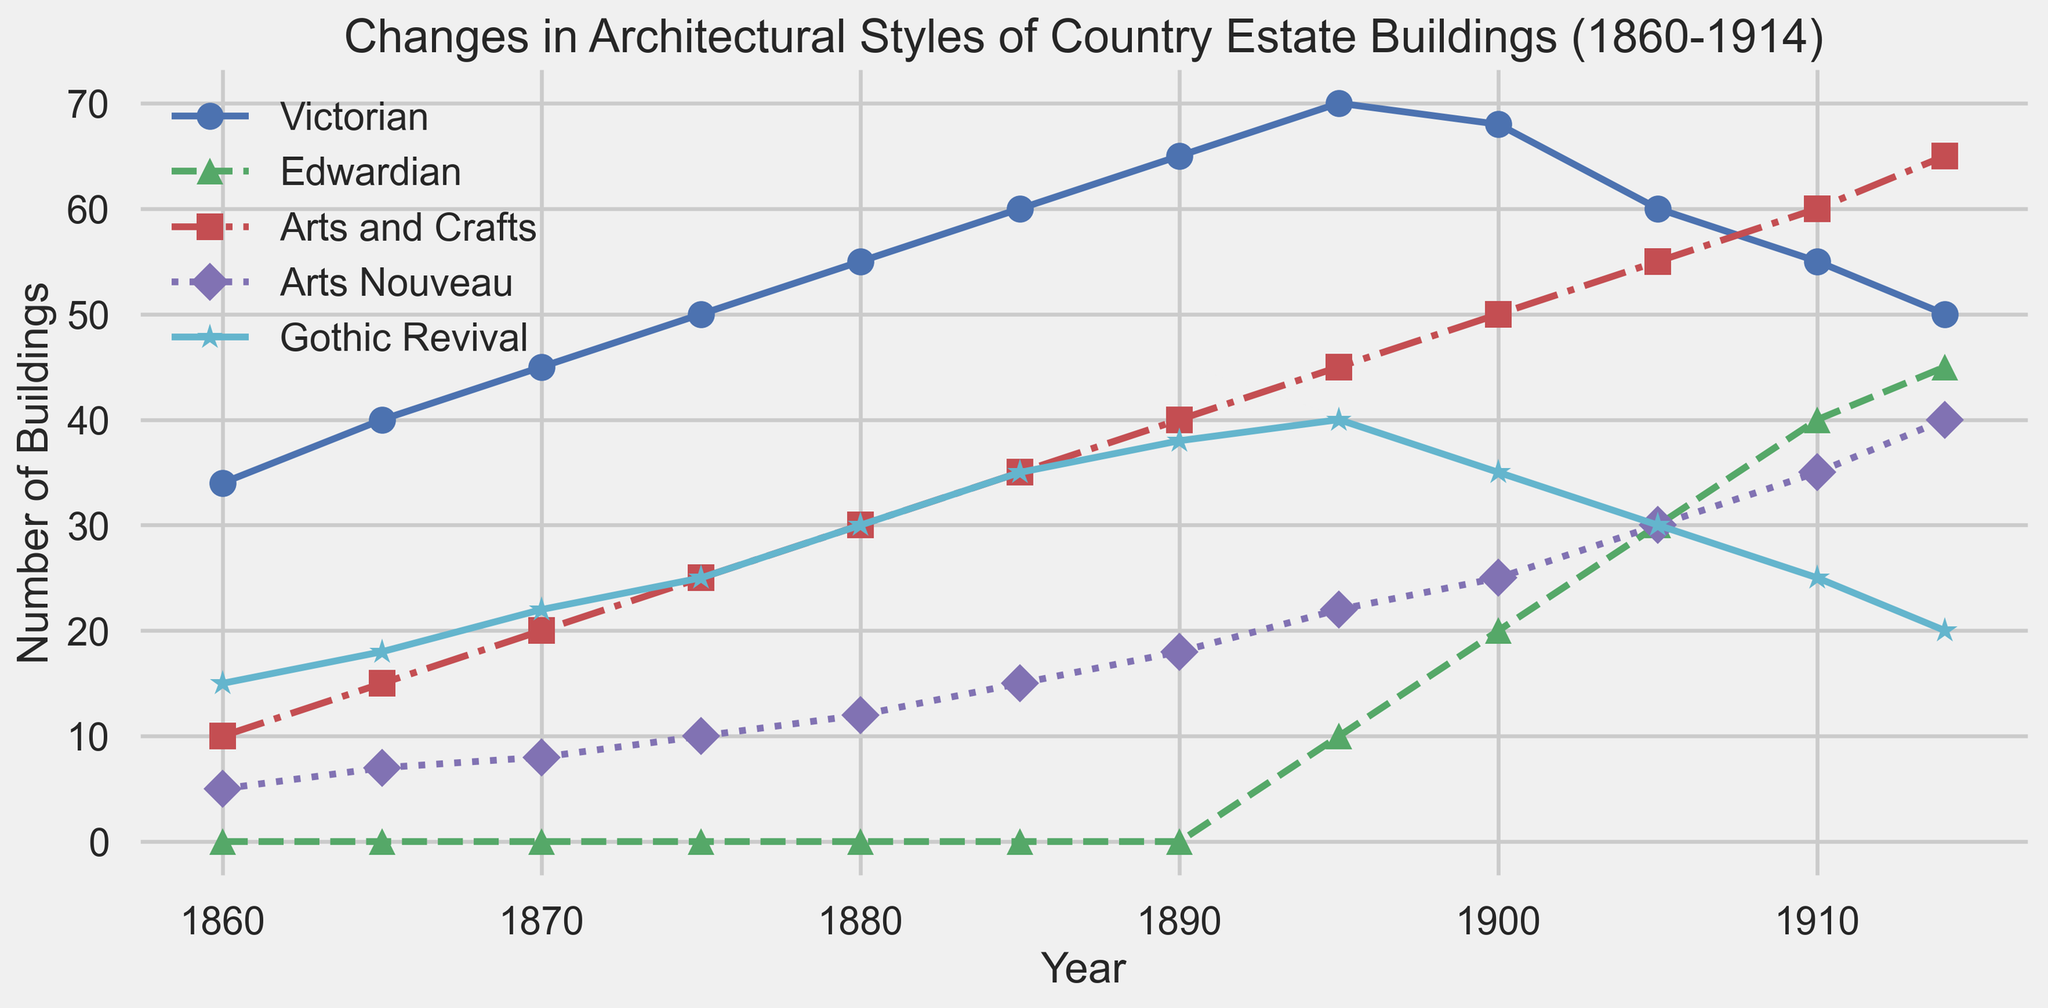What year did the Edwardian architectural style first appear in country estate buildings? The Edwardian style shows its first data point in 1895, where it starts with 10 buildings.
Answer: 1895 Which architectural style had the highest number of buildings in 1880? In 1880, the Victorian style had the highest number of buildings with a count of 55.
Answer: Victorian Comparing Arts and Crafts and Arts Nouveau in 1914, which style had more buildings and by how much? In 1914, Arts and Crafts had 65 buildings, and Arts Nouveau had 40 buildings. The difference is 65 - 40 = 25.
Answer: Arts and Crafts by 25 How did the number of Gothic Revival buildings change between 1860 and 1914? In 1860, there were 15 Gothic Revival buildings, and by 1914, the number was 20. The change is 20 - 15 = 5.
Answer: Increased by 5 What is the trend of Victorian buildings between 1900 and 1914? The number of Victorian buildings decreases over this period: from 68 in 1900 to 50 in 1914.
Answer: Decreasing trend Which architectural style shows the most significant increase from 1860 to 1914? Arts and Crafts had a significant increase from 10 buildings in 1860 to 65 buildings in 1914. The increase is 65 - 10 = 55.
Answer: Arts and Crafts What was the total number of Arts Nouveau buildings between 1860 and 1910? Adding the numbers from each year: 5 + 7 + 8 + 10 + 12 + 15 + 18 + 22 + 25 + 30 + 35 = 187.
Answer: 187 How many times does the Edwardian style surpass 30 buildings between 1860 and 1914? Edwardian buildings surpass 30 twice: in 1905 (30) and 1910 (40).
Answer: 2 times By how much did the number of Arts and Crafts buildings increase between 1880 and 1910? In 1880, there were 30 Arts and Crafts buildings, and in 1910, there were 60. The increase is 60 - 30 = 30.
Answer: 30 What year shows the most diverse range (maximum difference) in the number of buildings between the five architectural styles? In 1914, the counts are: Victorian (50), Edwardian (45), Arts and Crafts (65), Arts Nouveau (40), and Gothic Revival (20). The maximum range is 65 - 20 = 45.
Answer: 1914 